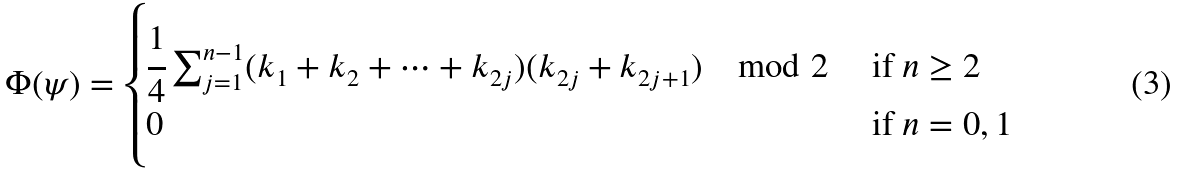Convert formula to latex. <formula><loc_0><loc_0><loc_500><loc_500>\Phi ( \psi ) = \begin{cases} \cfrac { 1 } { 4 } \sum _ { j = 1 } ^ { n - 1 } ( k _ { 1 } + k _ { 2 } + \dots + k _ { 2 j } ) ( k _ { 2 j } + k _ { 2 j + 1 } ) \mod 2 & \text { if } n \geq 2 \\ 0 & \text { if } n = 0 , 1 \end{cases}</formula> 